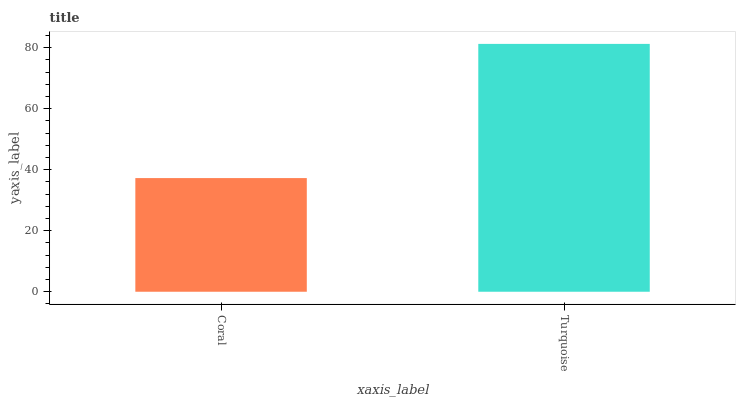Is Coral the minimum?
Answer yes or no. Yes. Is Turquoise the maximum?
Answer yes or no. Yes. Is Turquoise the minimum?
Answer yes or no. No. Is Turquoise greater than Coral?
Answer yes or no. Yes. Is Coral less than Turquoise?
Answer yes or no. Yes. Is Coral greater than Turquoise?
Answer yes or no. No. Is Turquoise less than Coral?
Answer yes or no. No. Is Turquoise the high median?
Answer yes or no. Yes. Is Coral the low median?
Answer yes or no. Yes. Is Coral the high median?
Answer yes or no. No. Is Turquoise the low median?
Answer yes or no. No. 